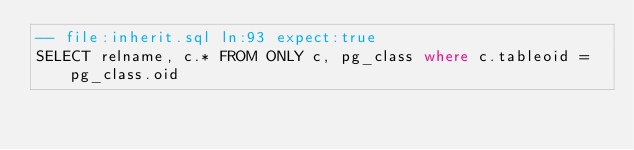<code> <loc_0><loc_0><loc_500><loc_500><_SQL_>-- file:inherit.sql ln:93 expect:true
SELECT relname, c.* FROM ONLY c, pg_class where c.tableoid = pg_class.oid
</code> 